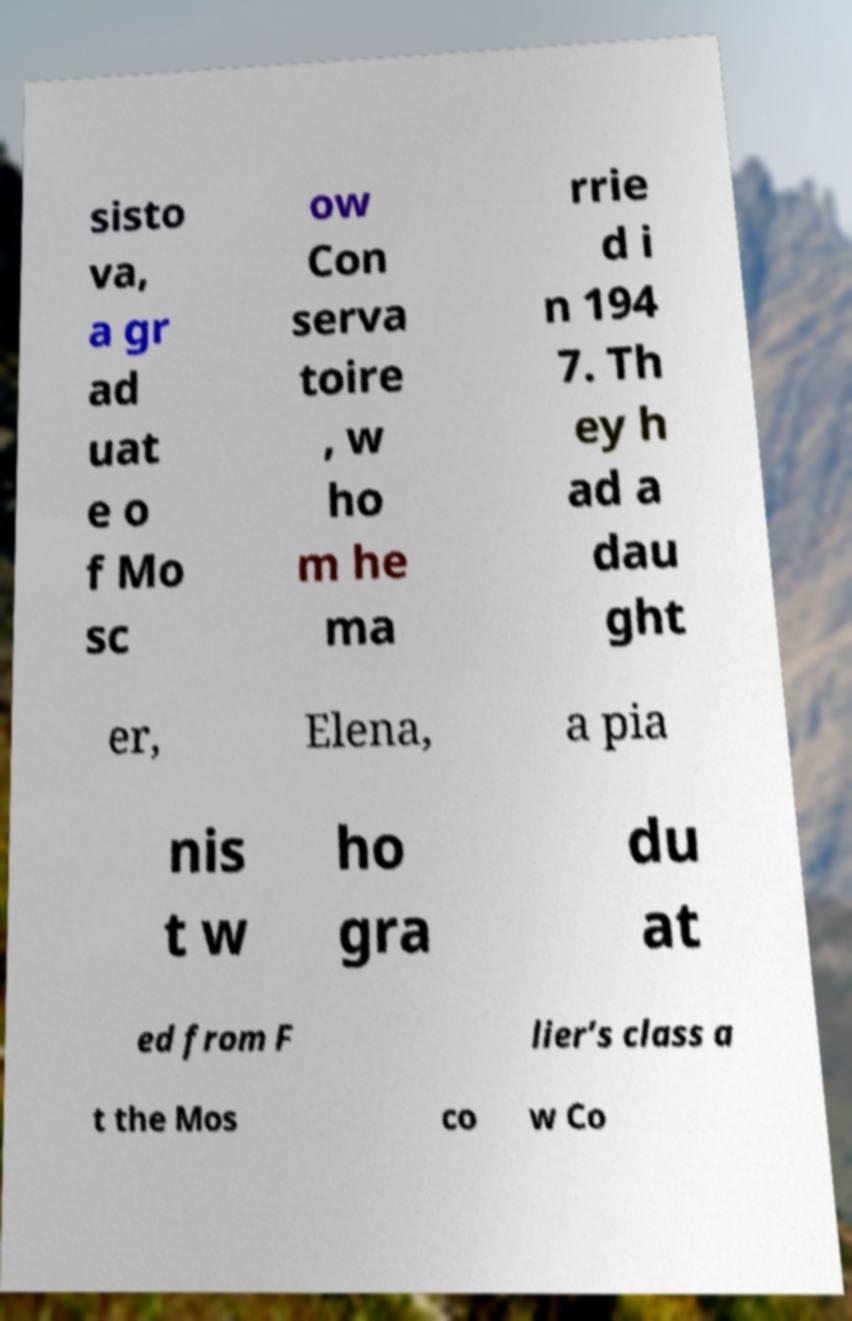Can you read and provide the text displayed in the image?This photo seems to have some interesting text. Can you extract and type it out for me? sisto va, a gr ad uat e o f Mo sc ow Con serva toire , w ho m he ma rrie d i n 194 7. Th ey h ad a dau ght er, Elena, a pia nis t w ho gra du at ed from F lier’s class a t the Mos co w Co 